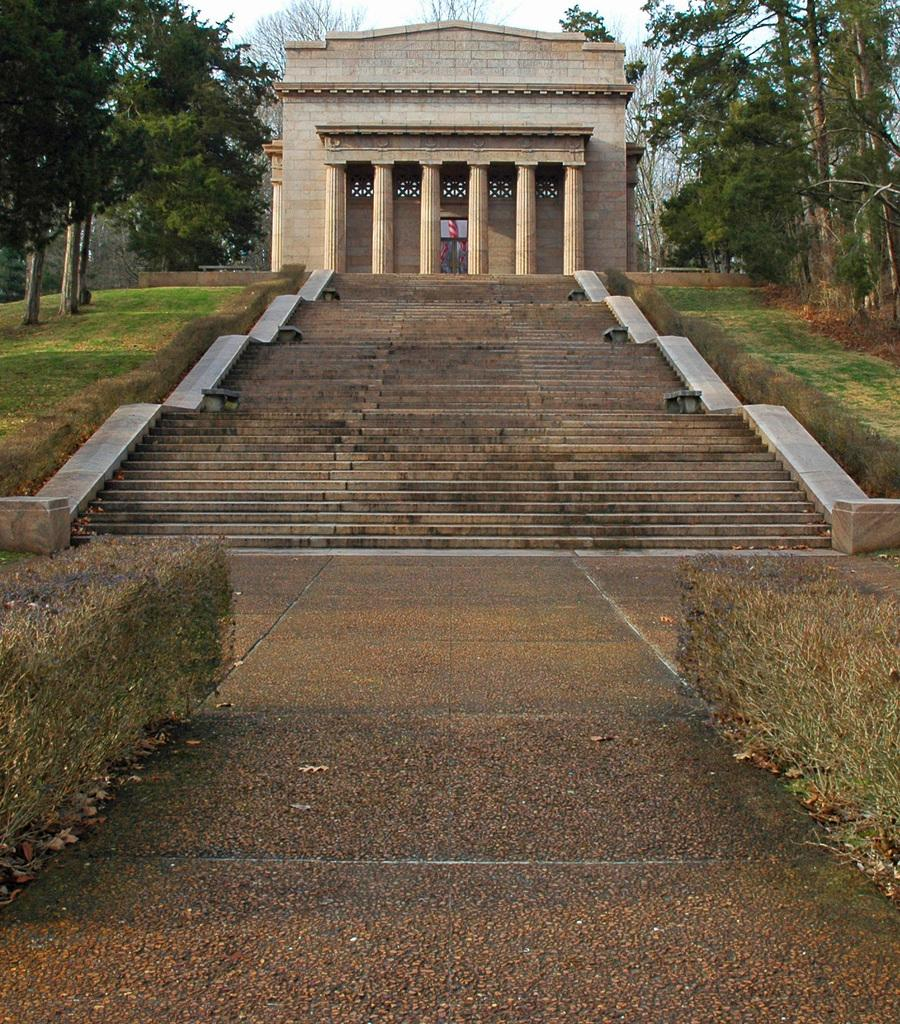What type of vegetation can be seen in the top right corner of the image? There are trees in the top right corner of the image. What type of vegetation can be seen in the left corner of the image? There are trees in the left corner of the image. Can you describe the tree in the middle of the image? There is a tree in the middle of the image. What year is depicted in the image? The image does not depict a specific year; it only shows trees in different locations. How many times does the tree in the middle of the image twist? The image does not provide information about the tree's twists; it only shows the tree's presence in the middle of the image. 